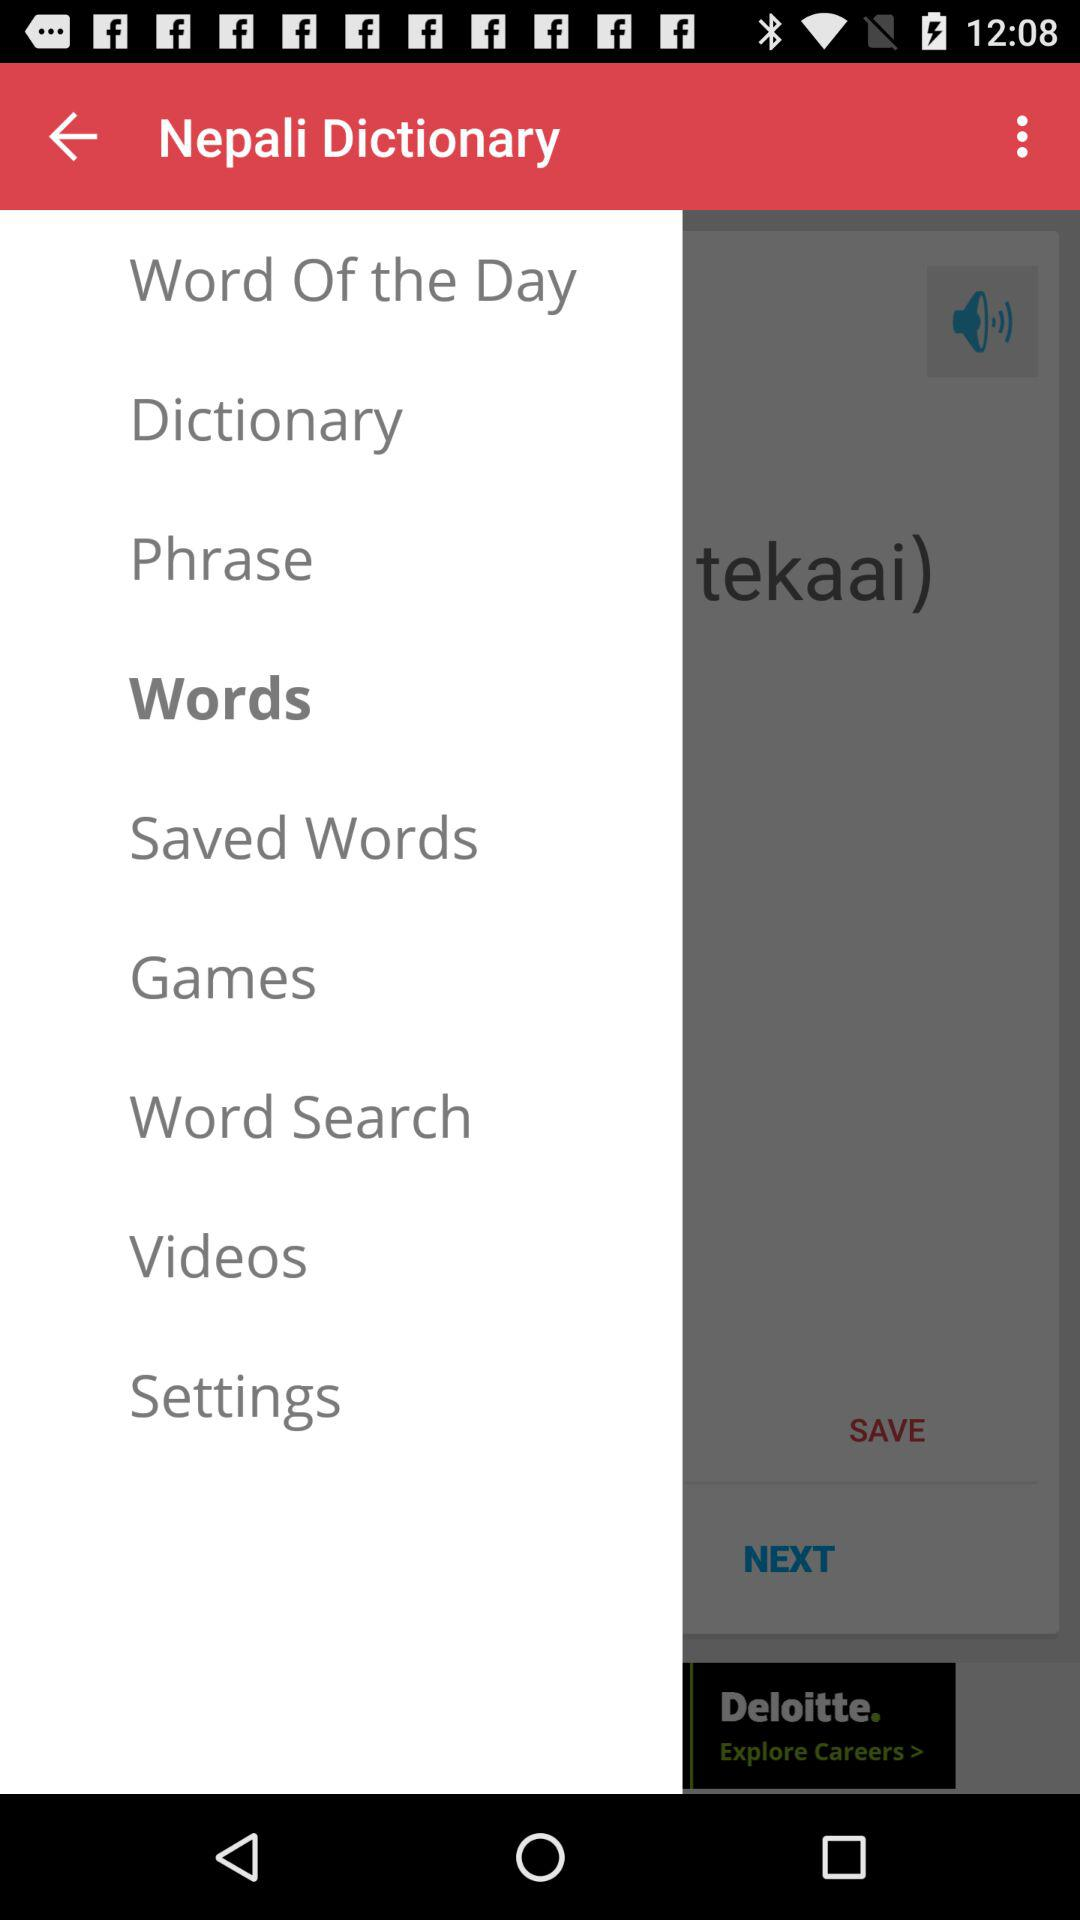What is the app name? The app name is "Nepali Dictionary". 